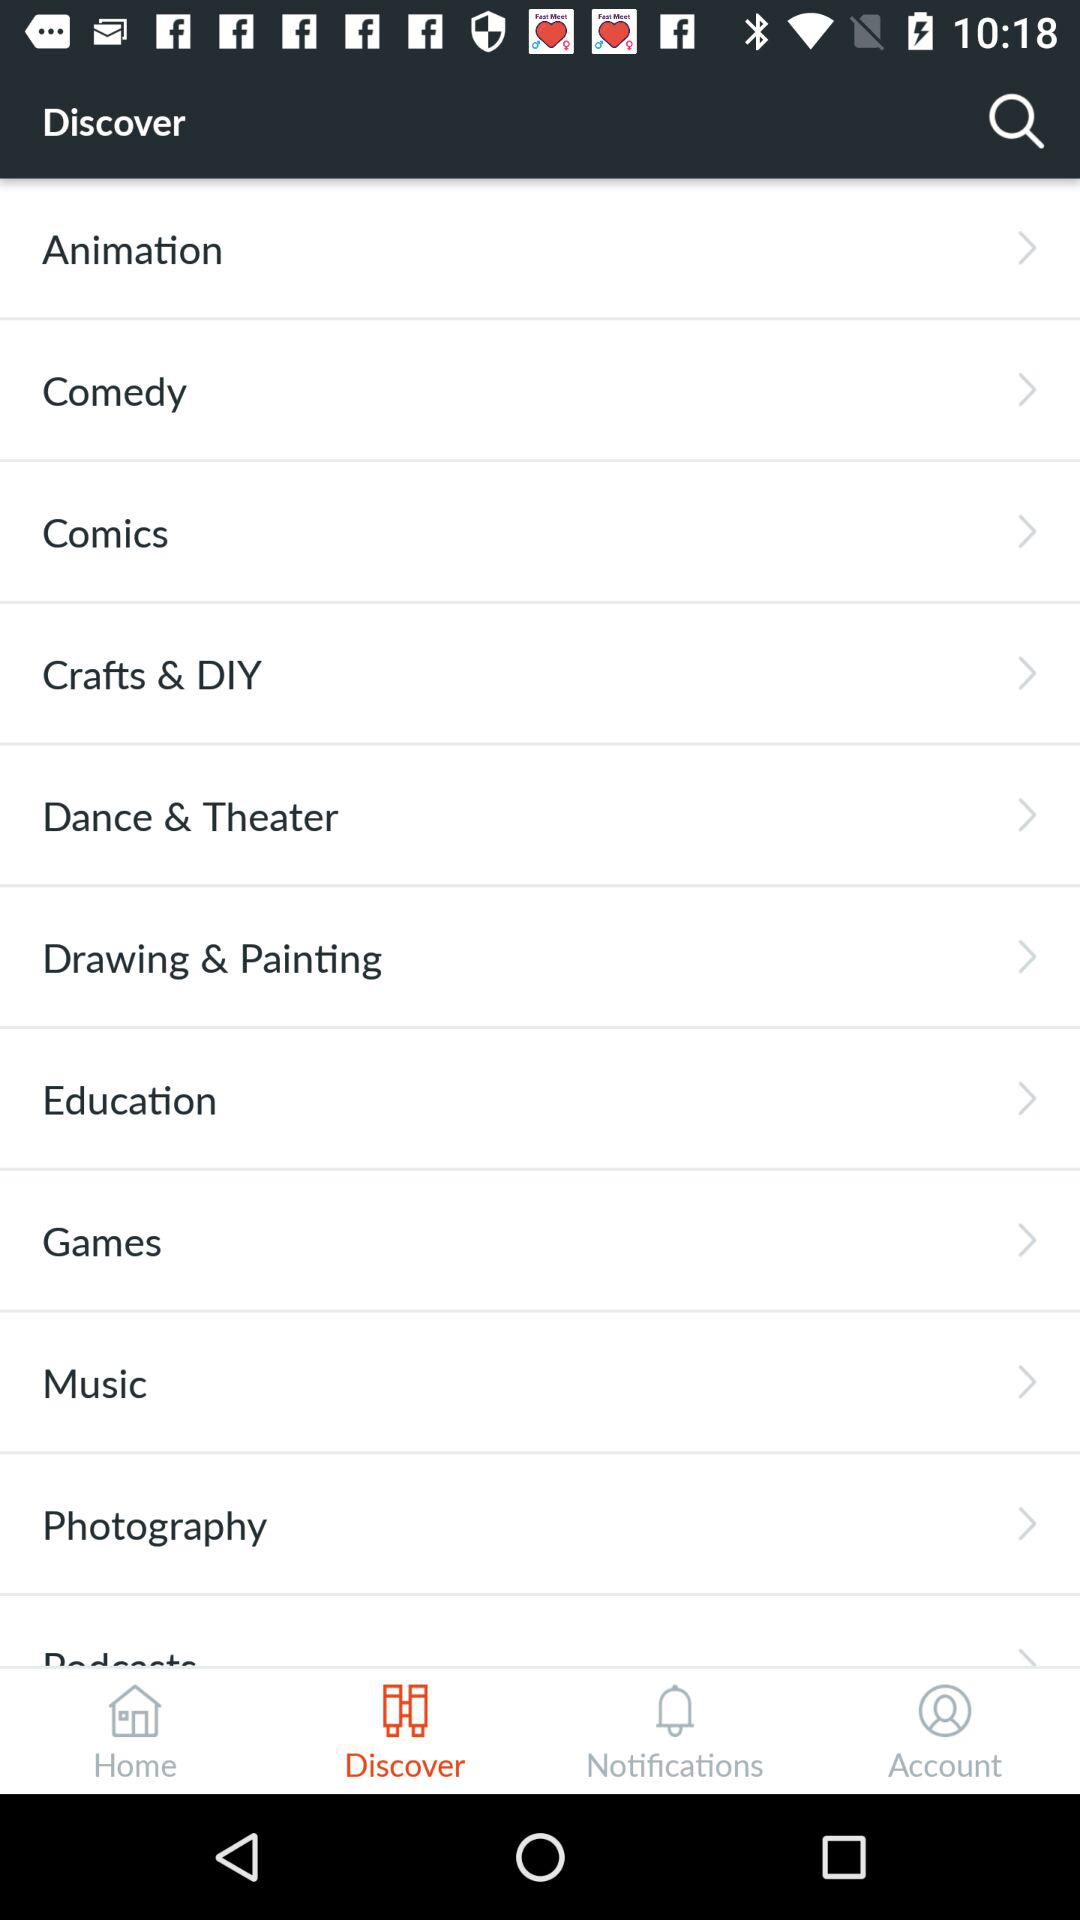Which tab is selected? The selected tab is "Discover". 